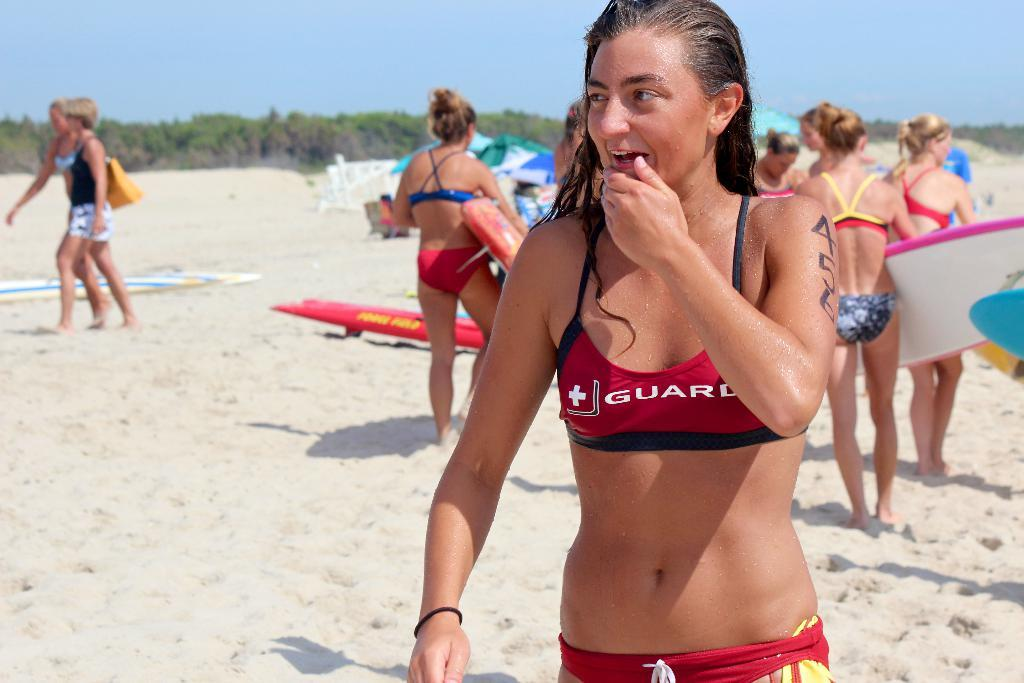<image>
Share a concise interpretation of the image provided. A girl in a bikini with brown hair in front on sand with people ,some holding surfboards behind her . 